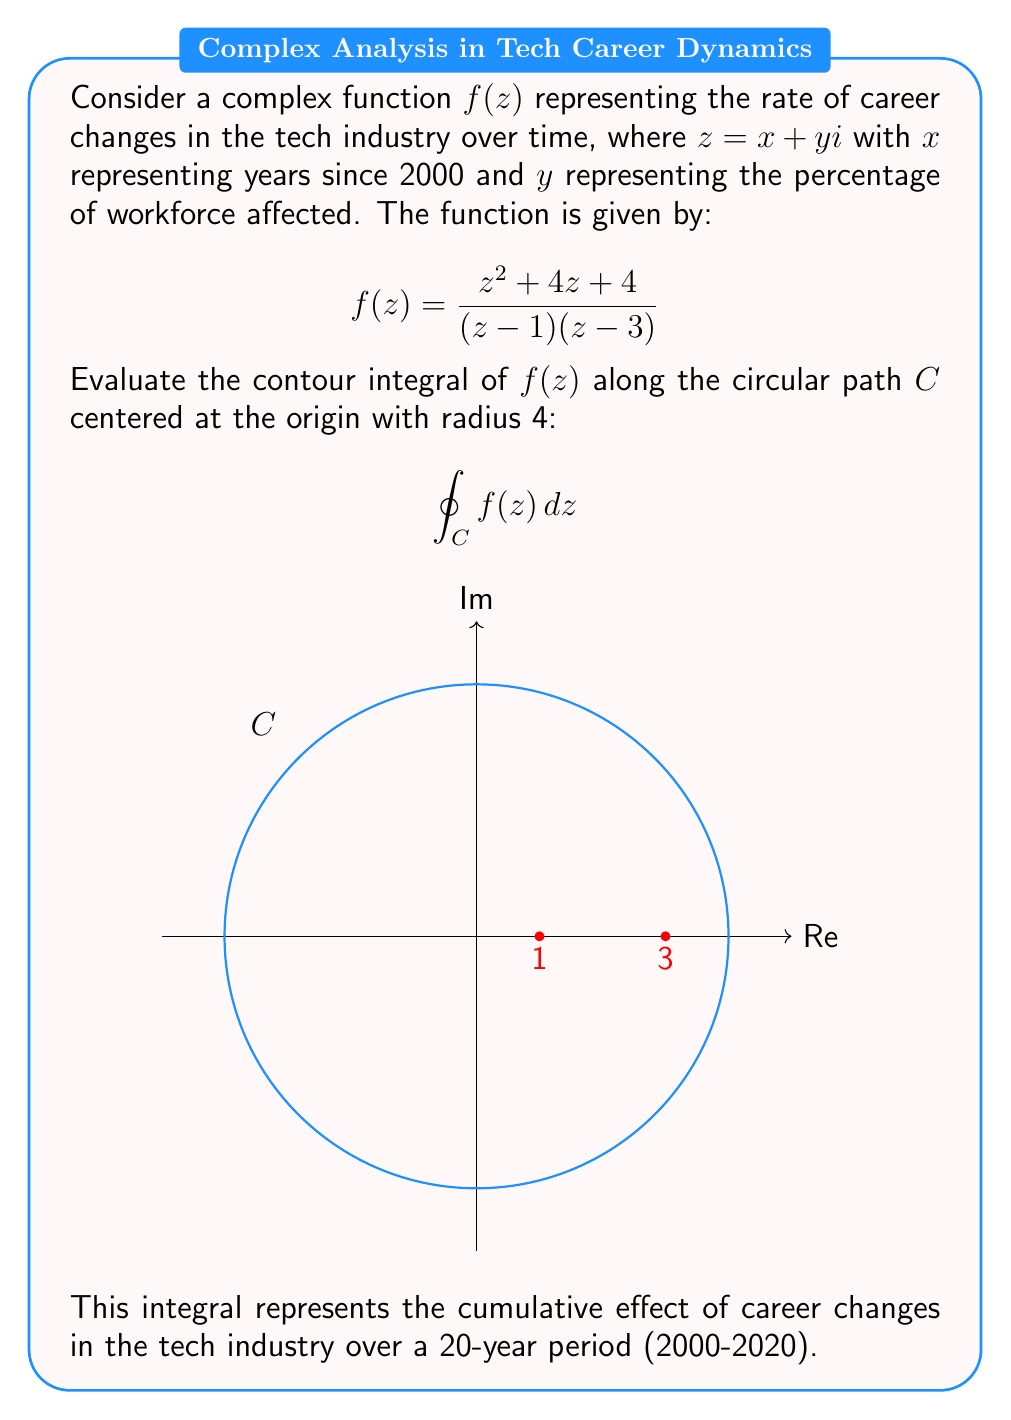Could you help me with this problem? To evaluate this contour integral, we'll use the Residue Theorem:

$$\oint_C f(z) dz = 2\pi i \sum_{k=1}^n \text{Res}(f, a_k)$$

where $a_k$ are the poles of $f(z)$ inside the contour $C$.

Step 1: Identify the poles
The poles are at $z=1$ and $z=3$, both of which lie inside the contour $C$.

Step 2: Calculate the residues
For $z=1$:
$$\text{Res}(f,1) = \lim_{z \to 1} (z-1)f(z) = \lim_{z \to 1} \frac{z^2 + 4z + 4}{z-3} = \frac{1^2 + 4(1) + 4}{1-3} = -\frac{9}{2}$$

For $z=3$:
$$\text{Res}(f,3) = \lim_{z \to 3} (z-3)f(z) = \lim_{z \to 3} \frac{z^2 + 4z + 4}{z-1} = \frac{3^2 + 4(3) + 4}{3-1} = \frac{25}{2}$$

Step 3: Apply the Residue Theorem
$$\oint_C f(z) dz = 2\pi i \left(\text{Res}(f,1) + \text{Res}(f,3)\right)$$
$$= 2\pi i \left(-\frac{9}{2} + \frac{25}{2}\right)$$
$$= 2\pi i \cdot \frac{16}{2}$$
$$= 16\pi i$$

This result represents the net effect of career changes in the tech industry over the 20-year period, with the imaginary unit $i$ indicating the cyclical nature of these changes.
Answer: $16\pi i$ 